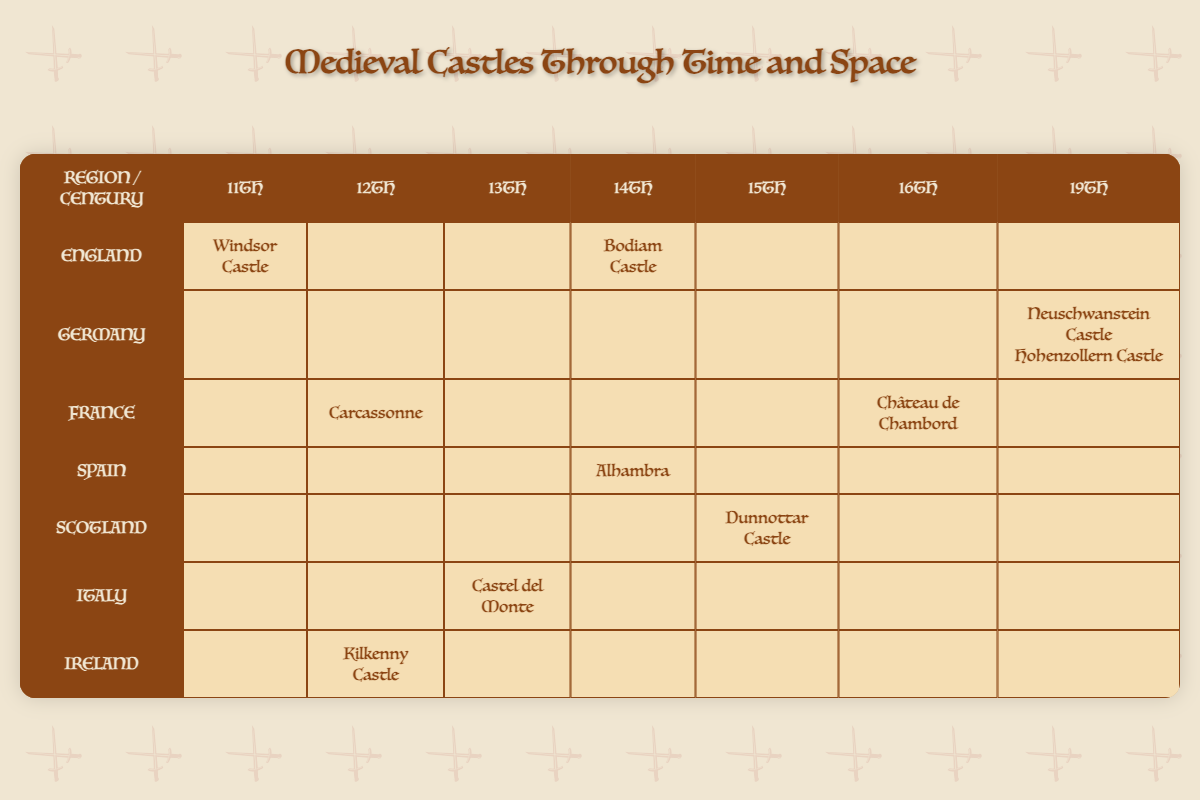What are the two castles listed for the 14th century in England? The table indicates that in England during the 14th century, the castles listed are Windsor Castle and Bodiam Castle.
Answer: Windsor Castle, Bodiam Castle Which region has the most castles listed in the 19th century? According to the table, Germany has two castles listed for the 19th century: Neuschwanstein Castle and Hohenzollern Castle, making it the region with the most castles for that century.
Answer: Germany Is Carcassonne located in Scotland? The table clearly shows that Carcassonne is in France, and there is no mention of it being located in Scotland, making the statement false.
Answer: No How many centuries are represented by castles in Ireland according to the table? In the table, Ireland has only one castle, Kilkenny Castle, listed under the 12th century, which means there is only one century represented.
Answer: One What is the earliest century in which a castle is listed from Germany? From the table, it can be seen that Germany has castles only listed for the 19th century, indicating that the earliest century represented there is also the 19th century, as no earlier entries are visible.
Answer: 19th century Which castle from Spain is listed in the table, and in which century was it built? The table reveals that the Alhambra is the castle listed from Spain, constructed during the 14th century.
Answer: Alhambra, 14th century Are there more castles listed in France than in Scotland? The table shows that France has two castles (Carcassonne in the 12th century and Château de Chambord in the 16th century), while Scotland has only one castle (Dunnottar Castle in the 15th century). Therefore, the statement is true.
Answer: Yes Which century has castles listed from the most number of regions? By examining the table, we see that the 14th century has castles from three distinct regions: England, Spain, and Italy. Checking other centuries reveals that no other century has castles from this many regions.
Answer: 14th century 